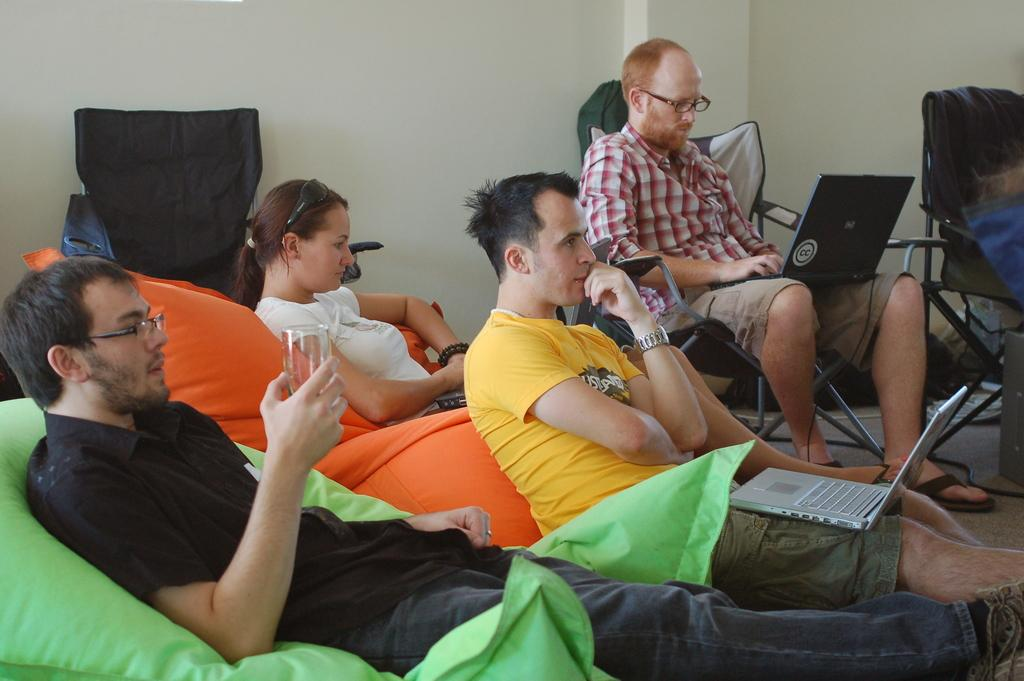How many people are in the image? There is a group of people in the image. What is one person holding in the image? One person is holding a glass. What can be seen in the background of the image? There is a wall in the background of the image. What type of tent is visible in the image? There is no tent present in the image. How many sides does the glass have in the image? The number of sides of the glass cannot be determined from the image alone, as it is a two-dimensional representation. 